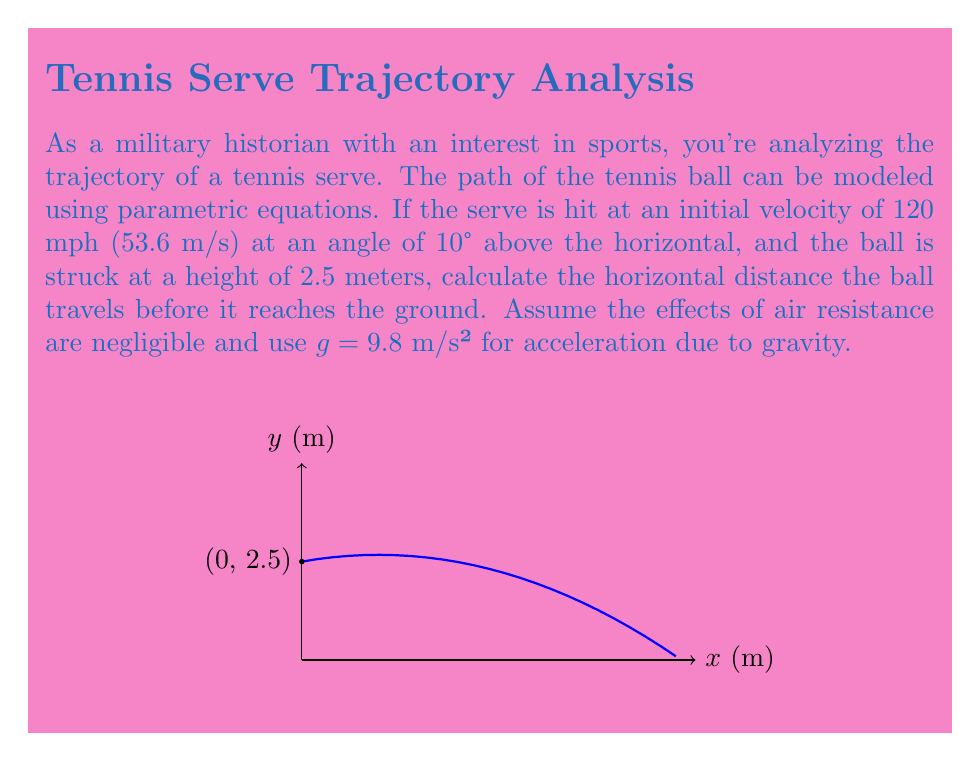Could you help me with this problem? Let's approach this step-by-step:

1) First, we need to break down the initial velocity into its horizontal and vertical components:
   $v_x = v \cos(\theta) = 53.6 \cos(10°) = 52.8$ m/s
   $v_y = v \sin(\theta) = 53.6 \sin(10°) = 9.31$ m/s

2) Now, we can set up our parametric equations:
   $x(t) = v_x t$
   $y(t) = v_y t - \frac{1}{2}gt^2 + y_0$

   Where $y_0 = 2.5$ m (initial height)

3) Substituting our values:
   $x(t) = 52.8t$
   $y(t) = 9.31t - 4.9t^2 + 2.5$

4) To find when the ball hits the ground, we need to solve $y(t) = 0$:
   $0 = 9.31t - 4.9t^2 + 2.5$
   $4.9t^2 - 9.31t - 2.5 = 0$

5) This is a quadratic equation. We can solve it using the quadratic formula:
   $t = \frac{-b \pm \sqrt{b^2 - 4ac}}{2a}$

   Where $a = 4.9$, $b = -9.31$, and $c = -2.5$

6) Solving this gives us two solutions: $t \approx 0.11$ s and $t \approx 1.79$ s
   The larger value is the time when the ball hits the ground.

7) Now we can find the horizontal distance by plugging this time into our $x(t)$ equation:
   $x(1.79) = 52.8 * 1.79 = 94.5$ m

Therefore, the ball travels approximately 94.5 meters horizontally before hitting the ground.
Answer: 94.5 m 